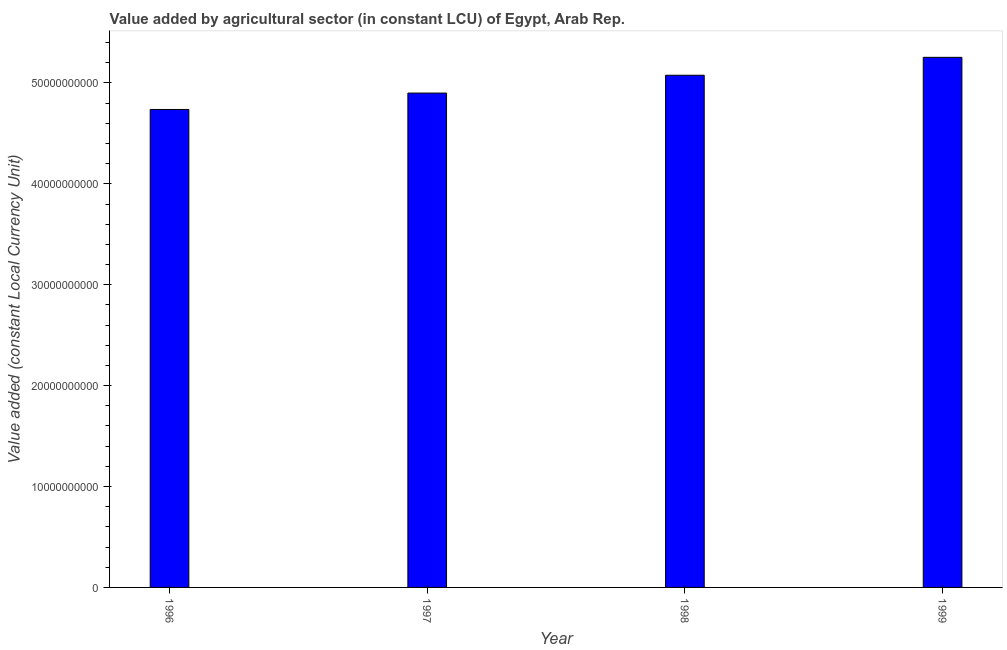What is the title of the graph?
Offer a very short reply. Value added by agricultural sector (in constant LCU) of Egypt, Arab Rep. What is the label or title of the Y-axis?
Your response must be concise. Value added (constant Local Currency Unit). What is the value added by agriculture sector in 1997?
Provide a succinct answer. 4.90e+1. Across all years, what is the maximum value added by agriculture sector?
Your response must be concise. 5.25e+1. Across all years, what is the minimum value added by agriculture sector?
Provide a short and direct response. 4.74e+1. In which year was the value added by agriculture sector minimum?
Offer a very short reply. 1996. What is the sum of the value added by agriculture sector?
Your answer should be compact. 2.00e+11. What is the difference between the value added by agriculture sector in 1997 and 1998?
Your response must be concise. -1.77e+09. What is the average value added by agriculture sector per year?
Your answer should be very brief. 4.99e+1. What is the median value added by agriculture sector?
Offer a very short reply. 4.99e+1. What is the ratio of the value added by agriculture sector in 1998 to that in 1999?
Give a very brief answer. 0.97. Is the value added by agriculture sector in 1997 less than that in 1998?
Offer a terse response. Yes. What is the difference between the highest and the second highest value added by agriculture sector?
Keep it short and to the point. 1.77e+09. Is the sum of the value added by agriculture sector in 1996 and 1997 greater than the maximum value added by agriculture sector across all years?
Your answer should be very brief. Yes. What is the difference between the highest and the lowest value added by agriculture sector?
Ensure brevity in your answer.  5.17e+09. In how many years, is the value added by agriculture sector greater than the average value added by agriculture sector taken over all years?
Provide a short and direct response. 2. How many bars are there?
Keep it short and to the point. 4. Are all the bars in the graph horizontal?
Give a very brief answer. No. How many years are there in the graph?
Provide a short and direct response. 4. What is the difference between two consecutive major ticks on the Y-axis?
Your response must be concise. 1.00e+1. Are the values on the major ticks of Y-axis written in scientific E-notation?
Your response must be concise. No. What is the Value added (constant Local Currency Unit) in 1996?
Your answer should be compact. 4.74e+1. What is the Value added (constant Local Currency Unit) in 1997?
Make the answer very short. 4.90e+1. What is the Value added (constant Local Currency Unit) of 1998?
Your answer should be compact. 5.08e+1. What is the Value added (constant Local Currency Unit) in 1999?
Your answer should be compact. 5.25e+1. What is the difference between the Value added (constant Local Currency Unit) in 1996 and 1997?
Make the answer very short. -1.63e+09. What is the difference between the Value added (constant Local Currency Unit) in 1996 and 1998?
Your answer should be very brief. -3.39e+09. What is the difference between the Value added (constant Local Currency Unit) in 1996 and 1999?
Provide a short and direct response. -5.17e+09. What is the difference between the Value added (constant Local Currency Unit) in 1997 and 1998?
Provide a succinct answer. -1.77e+09. What is the difference between the Value added (constant Local Currency Unit) in 1997 and 1999?
Make the answer very short. -3.54e+09. What is the difference between the Value added (constant Local Currency Unit) in 1998 and 1999?
Your answer should be very brief. -1.77e+09. What is the ratio of the Value added (constant Local Currency Unit) in 1996 to that in 1997?
Provide a short and direct response. 0.97. What is the ratio of the Value added (constant Local Currency Unit) in 1996 to that in 1998?
Make the answer very short. 0.93. What is the ratio of the Value added (constant Local Currency Unit) in 1996 to that in 1999?
Offer a terse response. 0.9. What is the ratio of the Value added (constant Local Currency Unit) in 1997 to that in 1999?
Make the answer very short. 0.93. What is the ratio of the Value added (constant Local Currency Unit) in 1998 to that in 1999?
Offer a terse response. 0.97. 